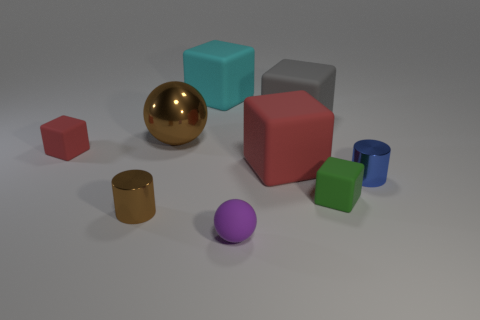There is a metal object that is the same color as the large ball; what shape is it?
Offer a terse response. Cylinder. What is the cube that is both behind the large red matte block and right of the small purple sphere made of?
Provide a succinct answer. Rubber. There is a red matte object that is to the left of the brown metallic sphere; does it have the same size as the large gray rubber object?
Keep it short and to the point. No. The large gray thing has what shape?
Keep it short and to the point. Cube. How many small green objects are the same shape as the large cyan matte object?
Your answer should be very brief. 1. What number of tiny rubber objects are both behind the small purple thing and right of the tiny brown cylinder?
Make the answer very short. 1. What color is the small matte ball?
Provide a succinct answer. Purple. Are there any cyan objects that have the same material as the small green object?
Your response must be concise. Yes. Is there a big matte thing in front of the red matte thing that is behind the big cube in front of the gray matte thing?
Make the answer very short. Yes. Are there any green objects on the left side of the blue shiny cylinder?
Give a very brief answer. Yes. 